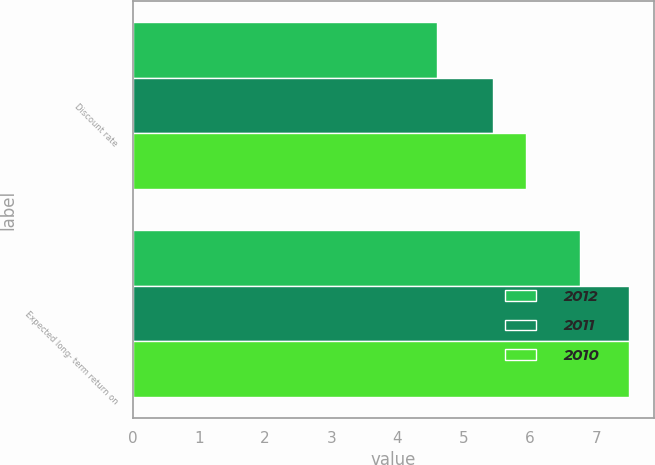Convert chart to OTSL. <chart><loc_0><loc_0><loc_500><loc_500><stacked_bar_chart><ecel><fcel>Discount rate<fcel>Expected long- term return on<nl><fcel>2012<fcel>4.59<fcel>6.75<nl><fcel>2011<fcel>5.44<fcel>7.5<nl><fcel>2010<fcel>5.94<fcel>7.5<nl></chart> 